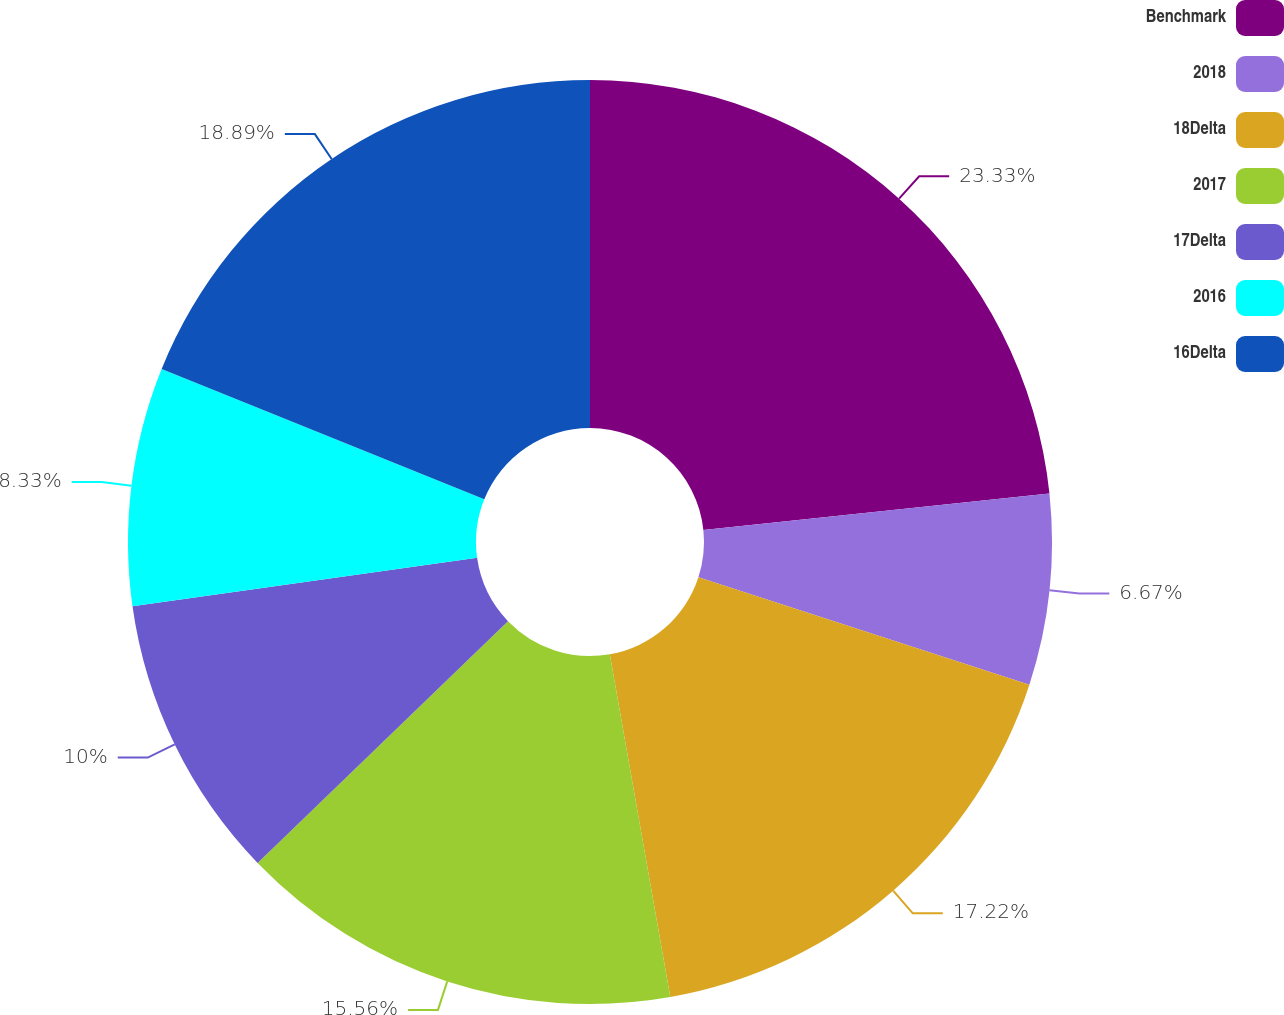<chart> <loc_0><loc_0><loc_500><loc_500><pie_chart><fcel>Benchmark<fcel>2018<fcel>18Delta<fcel>2017<fcel>17Delta<fcel>2016<fcel>16Delta<nl><fcel>23.33%<fcel>6.67%<fcel>17.22%<fcel>15.56%<fcel>10.0%<fcel>8.33%<fcel>18.89%<nl></chart> 